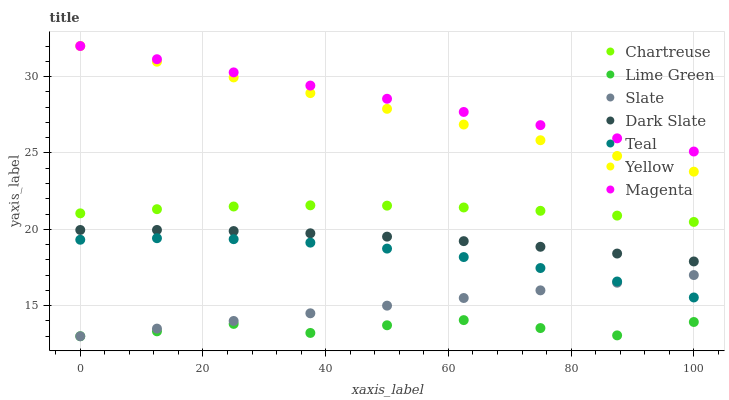Does Lime Green have the minimum area under the curve?
Answer yes or no. Yes. Does Magenta have the maximum area under the curve?
Answer yes or no. Yes. Does Yellow have the minimum area under the curve?
Answer yes or no. No. Does Yellow have the maximum area under the curve?
Answer yes or no. No. Is Slate the smoothest?
Answer yes or no. Yes. Is Lime Green the roughest?
Answer yes or no. Yes. Is Yellow the smoothest?
Answer yes or no. No. Is Yellow the roughest?
Answer yes or no. No. Does Slate have the lowest value?
Answer yes or no. Yes. Does Yellow have the lowest value?
Answer yes or no. No. Does Magenta have the highest value?
Answer yes or no. Yes. Does Dark Slate have the highest value?
Answer yes or no. No. Is Teal less than Dark Slate?
Answer yes or no. Yes. Is Dark Slate greater than Slate?
Answer yes or no. Yes. Does Teal intersect Slate?
Answer yes or no. Yes. Is Teal less than Slate?
Answer yes or no. No. Is Teal greater than Slate?
Answer yes or no. No. Does Teal intersect Dark Slate?
Answer yes or no. No. 